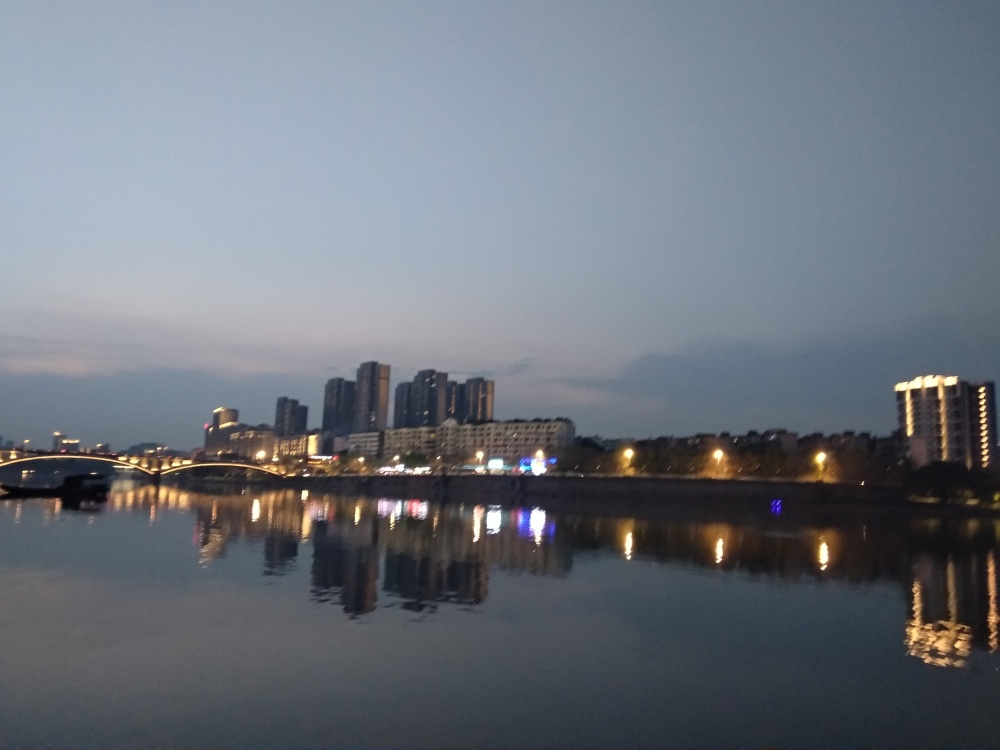What time of day was this photo taken? This photo appears to have been taken during twilight, just after the sun has set but before the sky goes completely dark. The remaining light in the sky and the artificial lights from the buildings suggest this transitional time of day. 